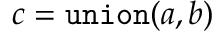<formula> <loc_0><loc_0><loc_500><loc_500>c = { \tt u n i o n } ( a , b )</formula> 